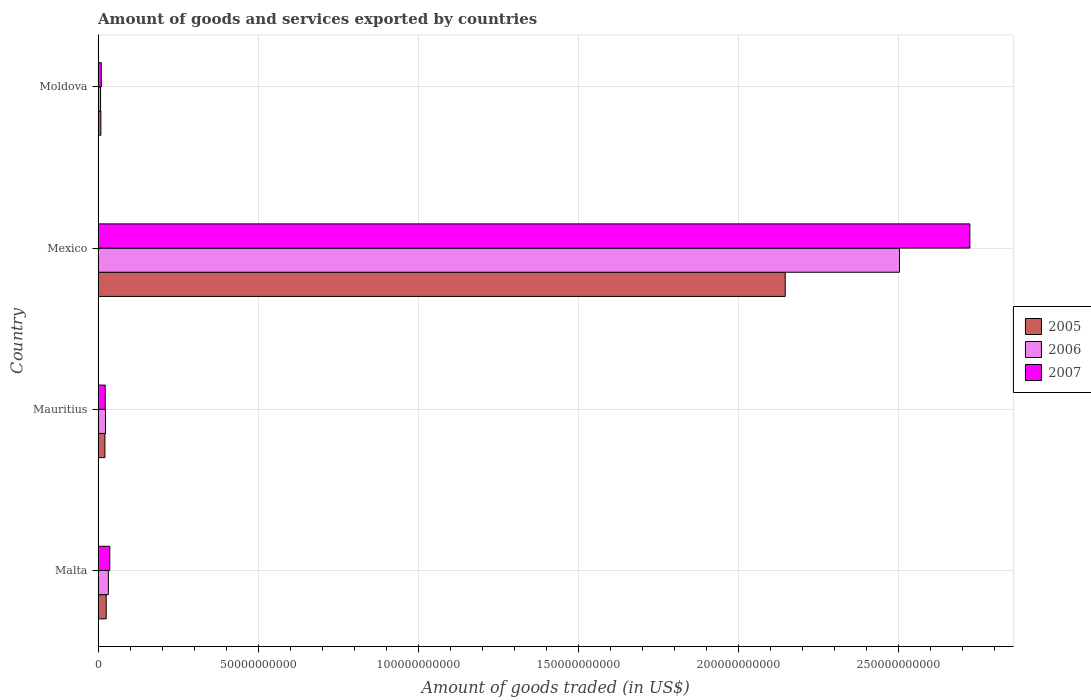How many different coloured bars are there?
Ensure brevity in your answer.  3. Are the number of bars per tick equal to the number of legend labels?
Your answer should be very brief. Yes. How many bars are there on the 4th tick from the top?
Your response must be concise. 3. How many bars are there on the 2nd tick from the bottom?
Make the answer very short. 3. What is the label of the 3rd group of bars from the top?
Offer a very short reply. Mauritius. What is the total amount of goods and services exported in 2006 in Moldova?
Give a very brief answer. 7.87e+08. Across all countries, what is the maximum total amount of goods and services exported in 2007?
Provide a succinct answer. 2.72e+11. Across all countries, what is the minimum total amount of goods and services exported in 2006?
Your answer should be very brief. 7.87e+08. In which country was the total amount of goods and services exported in 2005 maximum?
Provide a succinct answer. Mexico. In which country was the total amount of goods and services exported in 2006 minimum?
Make the answer very short. Moldova. What is the total total amount of goods and services exported in 2005 in the graph?
Your answer should be very brief. 2.20e+11. What is the difference between the total amount of goods and services exported in 2007 in Mauritius and that in Mexico?
Offer a terse response. -2.70e+11. What is the difference between the total amount of goods and services exported in 2005 in Mauritius and the total amount of goods and services exported in 2007 in Malta?
Give a very brief answer. -1.52e+09. What is the average total amount of goods and services exported in 2007 per country?
Your answer should be very brief. 6.98e+1. What is the difference between the total amount of goods and services exported in 2006 and total amount of goods and services exported in 2007 in Moldova?
Provide a short and direct response. -2.39e+08. What is the ratio of the total amount of goods and services exported in 2006 in Malta to that in Mexico?
Offer a very short reply. 0.01. Is the difference between the total amount of goods and services exported in 2006 in Mauritius and Moldova greater than the difference between the total amount of goods and services exported in 2007 in Mauritius and Moldova?
Your response must be concise. Yes. What is the difference between the highest and the second highest total amount of goods and services exported in 2007?
Ensure brevity in your answer.  2.69e+11. What is the difference between the highest and the lowest total amount of goods and services exported in 2006?
Provide a succinct answer. 2.50e+11. In how many countries, is the total amount of goods and services exported in 2007 greater than the average total amount of goods and services exported in 2007 taken over all countries?
Provide a succinct answer. 1. Are all the bars in the graph horizontal?
Your answer should be very brief. Yes. What is the difference between two consecutive major ticks on the X-axis?
Offer a very short reply. 5.00e+1. Where does the legend appear in the graph?
Offer a terse response. Center right. How many legend labels are there?
Your answer should be compact. 3. How are the legend labels stacked?
Your answer should be very brief. Vertical. What is the title of the graph?
Ensure brevity in your answer.  Amount of goods and services exported by countries. Does "1978" appear as one of the legend labels in the graph?
Provide a succinct answer. No. What is the label or title of the X-axis?
Keep it short and to the point. Amount of goods traded (in US$). What is the Amount of goods traded (in US$) in 2005 in Malta?
Offer a very short reply. 2.54e+09. What is the Amount of goods traded (in US$) of 2006 in Malta?
Make the answer very short. 3.23e+09. What is the Amount of goods traded (in US$) in 2007 in Malta?
Provide a succinct answer. 3.66e+09. What is the Amount of goods traded (in US$) in 2005 in Mauritius?
Offer a very short reply. 2.14e+09. What is the Amount of goods traded (in US$) of 2006 in Mauritius?
Offer a terse response. 2.33e+09. What is the Amount of goods traded (in US$) of 2007 in Mauritius?
Give a very brief answer. 2.24e+09. What is the Amount of goods traded (in US$) of 2005 in Mexico?
Provide a succinct answer. 2.15e+11. What is the Amount of goods traded (in US$) of 2006 in Mexico?
Ensure brevity in your answer.  2.50e+11. What is the Amount of goods traded (in US$) of 2007 in Mexico?
Offer a very short reply. 2.72e+11. What is the Amount of goods traded (in US$) of 2005 in Moldova?
Provide a short and direct response. 8.86e+08. What is the Amount of goods traded (in US$) in 2006 in Moldova?
Provide a short and direct response. 7.87e+08. What is the Amount of goods traded (in US$) in 2007 in Moldova?
Provide a succinct answer. 1.03e+09. Across all countries, what is the maximum Amount of goods traded (in US$) of 2005?
Keep it short and to the point. 2.15e+11. Across all countries, what is the maximum Amount of goods traded (in US$) in 2006?
Your answer should be compact. 2.50e+11. Across all countries, what is the maximum Amount of goods traded (in US$) in 2007?
Your response must be concise. 2.72e+11. Across all countries, what is the minimum Amount of goods traded (in US$) of 2005?
Make the answer very short. 8.86e+08. Across all countries, what is the minimum Amount of goods traded (in US$) in 2006?
Make the answer very short. 7.87e+08. Across all countries, what is the minimum Amount of goods traded (in US$) in 2007?
Give a very brief answer. 1.03e+09. What is the total Amount of goods traded (in US$) in 2005 in the graph?
Your answer should be very brief. 2.20e+11. What is the total Amount of goods traded (in US$) of 2006 in the graph?
Offer a terse response. 2.57e+11. What is the total Amount of goods traded (in US$) of 2007 in the graph?
Provide a succinct answer. 2.79e+11. What is the difference between the Amount of goods traded (in US$) in 2005 in Malta and that in Mauritius?
Give a very brief answer. 4.06e+08. What is the difference between the Amount of goods traded (in US$) of 2006 in Malta and that in Mauritius?
Your response must be concise. 8.99e+08. What is the difference between the Amount of goods traded (in US$) of 2007 in Malta and that in Mauritius?
Keep it short and to the point. 1.42e+09. What is the difference between the Amount of goods traded (in US$) of 2005 in Malta and that in Mexico?
Ensure brevity in your answer.  -2.12e+11. What is the difference between the Amount of goods traded (in US$) of 2006 in Malta and that in Mexico?
Offer a terse response. -2.47e+11. What is the difference between the Amount of goods traded (in US$) in 2007 in Malta and that in Mexico?
Provide a succinct answer. -2.69e+11. What is the difference between the Amount of goods traded (in US$) of 2005 in Malta and that in Moldova?
Offer a very short reply. 1.66e+09. What is the difference between the Amount of goods traded (in US$) of 2006 in Malta and that in Moldova?
Provide a short and direct response. 2.44e+09. What is the difference between the Amount of goods traded (in US$) in 2007 in Malta and that in Moldova?
Give a very brief answer. 2.63e+09. What is the difference between the Amount of goods traded (in US$) of 2005 in Mauritius and that in Mexico?
Make the answer very short. -2.12e+11. What is the difference between the Amount of goods traded (in US$) of 2006 in Mauritius and that in Mexico?
Your answer should be compact. -2.48e+11. What is the difference between the Amount of goods traded (in US$) in 2007 in Mauritius and that in Mexico?
Your response must be concise. -2.70e+11. What is the difference between the Amount of goods traded (in US$) of 2005 in Mauritius and that in Moldova?
Offer a terse response. 1.25e+09. What is the difference between the Amount of goods traded (in US$) of 2006 in Mauritius and that in Moldova?
Offer a terse response. 1.54e+09. What is the difference between the Amount of goods traded (in US$) of 2007 in Mauritius and that in Moldova?
Keep it short and to the point. 1.21e+09. What is the difference between the Amount of goods traded (in US$) in 2005 in Mexico and that in Moldova?
Provide a short and direct response. 2.14e+11. What is the difference between the Amount of goods traded (in US$) in 2006 in Mexico and that in Moldova?
Provide a succinct answer. 2.50e+11. What is the difference between the Amount of goods traded (in US$) of 2007 in Mexico and that in Moldova?
Give a very brief answer. 2.71e+11. What is the difference between the Amount of goods traded (in US$) of 2005 in Malta and the Amount of goods traded (in US$) of 2006 in Mauritius?
Provide a succinct answer. 2.16e+08. What is the difference between the Amount of goods traded (in US$) in 2005 in Malta and the Amount of goods traded (in US$) in 2007 in Mauritius?
Offer a very short reply. 3.07e+08. What is the difference between the Amount of goods traded (in US$) of 2006 in Malta and the Amount of goods traded (in US$) of 2007 in Mauritius?
Keep it short and to the point. 9.90e+08. What is the difference between the Amount of goods traded (in US$) of 2005 in Malta and the Amount of goods traded (in US$) of 2006 in Mexico?
Offer a very short reply. -2.48e+11. What is the difference between the Amount of goods traded (in US$) of 2005 in Malta and the Amount of goods traded (in US$) of 2007 in Mexico?
Provide a succinct answer. -2.70e+11. What is the difference between the Amount of goods traded (in US$) in 2006 in Malta and the Amount of goods traded (in US$) in 2007 in Mexico?
Ensure brevity in your answer.  -2.69e+11. What is the difference between the Amount of goods traded (in US$) of 2005 in Malta and the Amount of goods traded (in US$) of 2006 in Moldova?
Keep it short and to the point. 1.76e+09. What is the difference between the Amount of goods traded (in US$) of 2005 in Malta and the Amount of goods traded (in US$) of 2007 in Moldova?
Your response must be concise. 1.52e+09. What is the difference between the Amount of goods traded (in US$) in 2006 in Malta and the Amount of goods traded (in US$) in 2007 in Moldova?
Offer a very short reply. 2.20e+09. What is the difference between the Amount of goods traded (in US$) of 2005 in Mauritius and the Amount of goods traded (in US$) of 2006 in Mexico?
Provide a succinct answer. -2.48e+11. What is the difference between the Amount of goods traded (in US$) of 2005 in Mauritius and the Amount of goods traded (in US$) of 2007 in Mexico?
Your answer should be very brief. -2.70e+11. What is the difference between the Amount of goods traded (in US$) in 2006 in Mauritius and the Amount of goods traded (in US$) in 2007 in Mexico?
Ensure brevity in your answer.  -2.70e+11. What is the difference between the Amount of goods traded (in US$) of 2005 in Mauritius and the Amount of goods traded (in US$) of 2006 in Moldova?
Provide a short and direct response. 1.35e+09. What is the difference between the Amount of goods traded (in US$) in 2005 in Mauritius and the Amount of goods traded (in US$) in 2007 in Moldova?
Your answer should be compact. 1.11e+09. What is the difference between the Amount of goods traded (in US$) in 2006 in Mauritius and the Amount of goods traded (in US$) in 2007 in Moldova?
Give a very brief answer. 1.30e+09. What is the difference between the Amount of goods traded (in US$) in 2005 in Mexico and the Amount of goods traded (in US$) in 2006 in Moldova?
Keep it short and to the point. 2.14e+11. What is the difference between the Amount of goods traded (in US$) in 2005 in Mexico and the Amount of goods traded (in US$) in 2007 in Moldova?
Provide a short and direct response. 2.14e+11. What is the difference between the Amount of goods traded (in US$) of 2006 in Mexico and the Amount of goods traded (in US$) of 2007 in Moldova?
Ensure brevity in your answer.  2.49e+11. What is the average Amount of goods traded (in US$) in 2005 per country?
Give a very brief answer. 5.51e+1. What is the average Amount of goods traded (in US$) of 2006 per country?
Provide a short and direct response. 6.42e+1. What is the average Amount of goods traded (in US$) in 2007 per country?
Provide a succinct answer. 6.98e+1. What is the difference between the Amount of goods traded (in US$) in 2005 and Amount of goods traded (in US$) in 2006 in Malta?
Give a very brief answer. -6.83e+08. What is the difference between the Amount of goods traded (in US$) of 2005 and Amount of goods traded (in US$) of 2007 in Malta?
Your answer should be compact. -1.11e+09. What is the difference between the Amount of goods traded (in US$) of 2006 and Amount of goods traded (in US$) of 2007 in Malta?
Provide a succinct answer. -4.30e+08. What is the difference between the Amount of goods traded (in US$) in 2005 and Amount of goods traded (in US$) in 2006 in Mauritius?
Keep it short and to the point. -1.90e+08. What is the difference between the Amount of goods traded (in US$) in 2005 and Amount of goods traded (in US$) in 2007 in Mauritius?
Provide a short and direct response. -9.95e+07. What is the difference between the Amount of goods traded (in US$) in 2006 and Amount of goods traded (in US$) in 2007 in Mauritius?
Make the answer very short. 9.09e+07. What is the difference between the Amount of goods traded (in US$) of 2005 and Amount of goods traded (in US$) of 2006 in Mexico?
Offer a terse response. -3.57e+1. What is the difference between the Amount of goods traded (in US$) in 2005 and Amount of goods traded (in US$) in 2007 in Mexico?
Offer a terse response. -5.77e+1. What is the difference between the Amount of goods traded (in US$) of 2006 and Amount of goods traded (in US$) of 2007 in Mexico?
Make the answer very short. -2.20e+1. What is the difference between the Amount of goods traded (in US$) in 2005 and Amount of goods traded (in US$) in 2006 in Moldova?
Ensure brevity in your answer.  9.92e+07. What is the difference between the Amount of goods traded (in US$) in 2005 and Amount of goods traded (in US$) in 2007 in Moldova?
Ensure brevity in your answer.  -1.40e+08. What is the difference between the Amount of goods traded (in US$) in 2006 and Amount of goods traded (in US$) in 2007 in Moldova?
Make the answer very short. -2.39e+08. What is the ratio of the Amount of goods traded (in US$) in 2005 in Malta to that in Mauritius?
Give a very brief answer. 1.19. What is the ratio of the Amount of goods traded (in US$) in 2006 in Malta to that in Mauritius?
Make the answer very short. 1.39. What is the ratio of the Amount of goods traded (in US$) in 2007 in Malta to that in Mauritius?
Offer a very short reply. 1.63. What is the ratio of the Amount of goods traded (in US$) in 2005 in Malta to that in Mexico?
Ensure brevity in your answer.  0.01. What is the ratio of the Amount of goods traded (in US$) of 2006 in Malta to that in Mexico?
Your answer should be compact. 0.01. What is the ratio of the Amount of goods traded (in US$) of 2007 in Malta to that in Mexico?
Your answer should be compact. 0.01. What is the ratio of the Amount of goods traded (in US$) in 2005 in Malta to that in Moldova?
Your answer should be compact. 2.87. What is the ratio of the Amount of goods traded (in US$) of 2006 in Malta to that in Moldova?
Provide a succinct answer. 4.1. What is the ratio of the Amount of goods traded (in US$) of 2007 in Malta to that in Moldova?
Give a very brief answer. 3.56. What is the ratio of the Amount of goods traded (in US$) in 2006 in Mauritius to that in Mexico?
Provide a succinct answer. 0.01. What is the ratio of the Amount of goods traded (in US$) of 2007 in Mauritius to that in Mexico?
Make the answer very short. 0.01. What is the ratio of the Amount of goods traded (in US$) in 2005 in Mauritius to that in Moldova?
Provide a succinct answer. 2.41. What is the ratio of the Amount of goods traded (in US$) of 2006 in Mauritius to that in Moldova?
Your answer should be very brief. 2.96. What is the ratio of the Amount of goods traded (in US$) in 2007 in Mauritius to that in Moldova?
Your answer should be very brief. 2.18. What is the ratio of the Amount of goods traded (in US$) in 2005 in Mexico to that in Moldova?
Give a very brief answer. 242.22. What is the ratio of the Amount of goods traded (in US$) of 2006 in Mexico to that in Moldova?
Make the answer very short. 318.09. What is the ratio of the Amount of goods traded (in US$) of 2007 in Mexico to that in Moldova?
Provide a short and direct response. 265.39. What is the difference between the highest and the second highest Amount of goods traded (in US$) in 2005?
Provide a succinct answer. 2.12e+11. What is the difference between the highest and the second highest Amount of goods traded (in US$) in 2006?
Your answer should be very brief. 2.47e+11. What is the difference between the highest and the second highest Amount of goods traded (in US$) in 2007?
Your response must be concise. 2.69e+11. What is the difference between the highest and the lowest Amount of goods traded (in US$) in 2005?
Ensure brevity in your answer.  2.14e+11. What is the difference between the highest and the lowest Amount of goods traded (in US$) in 2006?
Your answer should be very brief. 2.50e+11. What is the difference between the highest and the lowest Amount of goods traded (in US$) in 2007?
Your response must be concise. 2.71e+11. 